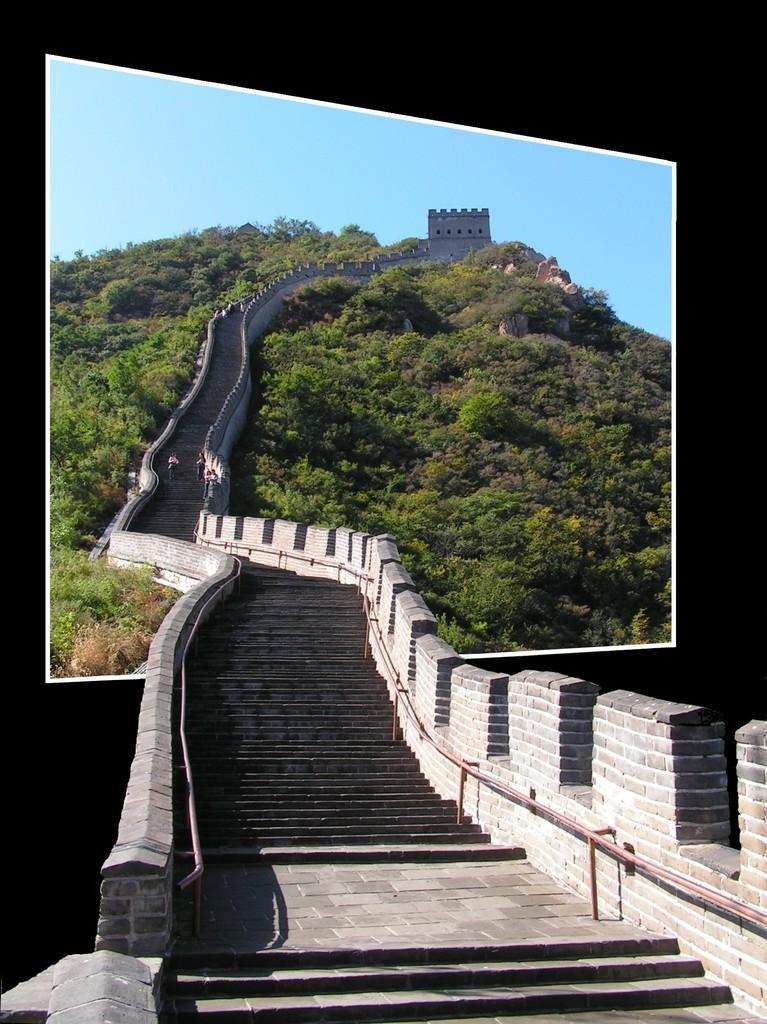Please provide a concise description of this image. In this picture we can observe steps and some trees. There is a hill. In the background we can observe a sky. 